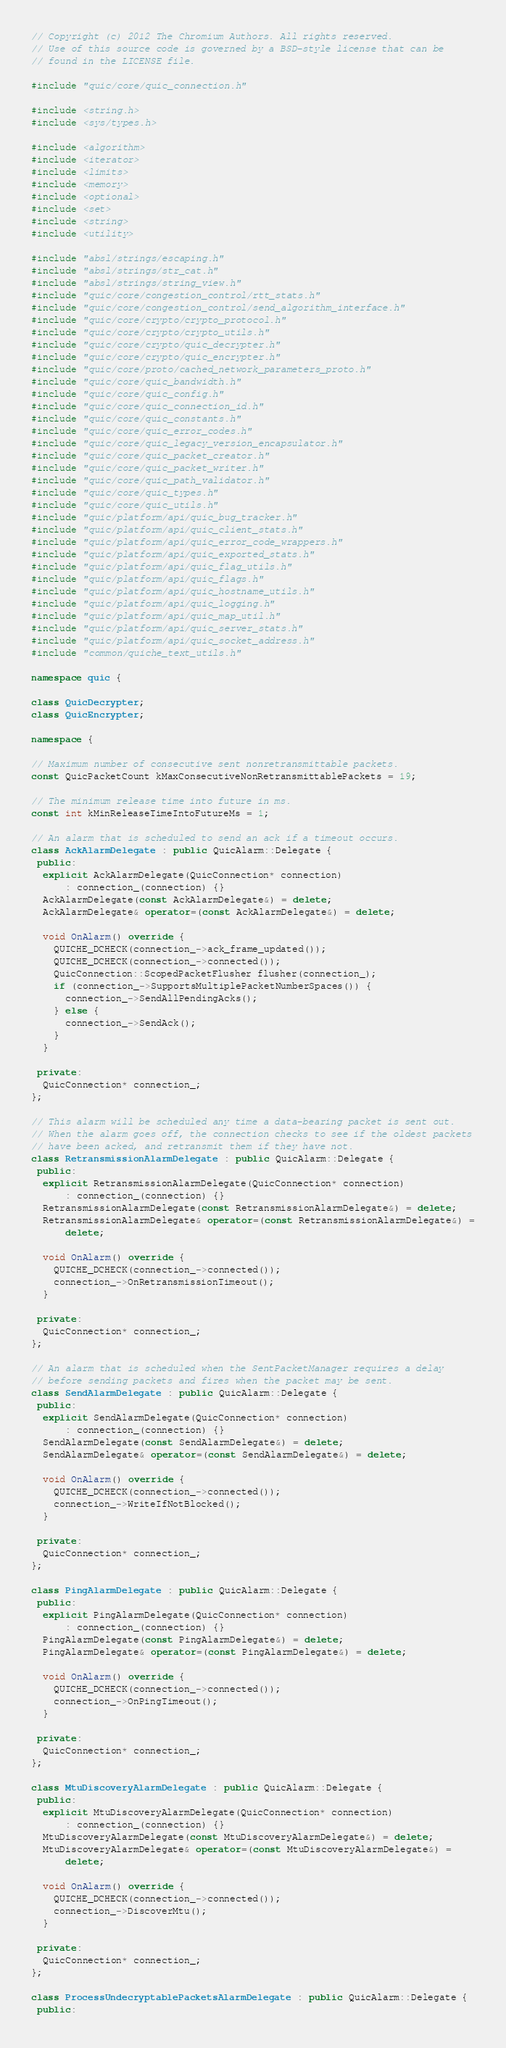Convert code to text. <code><loc_0><loc_0><loc_500><loc_500><_C++_>// Copyright (c) 2012 The Chromium Authors. All rights reserved.
// Use of this source code is governed by a BSD-style license that can be
// found in the LICENSE file.

#include "quic/core/quic_connection.h"

#include <string.h>
#include <sys/types.h>

#include <algorithm>
#include <iterator>
#include <limits>
#include <memory>
#include <optional>
#include <set>
#include <string>
#include <utility>

#include "absl/strings/escaping.h"
#include "absl/strings/str_cat.h"
#include "absl/strings/string_view.h"
#include "quic/core/congestion_control/rtt_stats.h"
#include "quic/core/congestion_control/send_algorithm_interface.h"
#include "quic/core/crypto/crypto_protocol.h"
#include "quic/core/crypto/crypto_utils.h"
#include "quic/core/crypto/quic_decrypter.h"
#include "quic/core/crypto/quic_encrypter.h"
#include "quic/core/proto/cached_network_parameters_proto.h"
#include "quic/core/quic_bandwidth.h"
#include "quic/core/quic_config.h"
#include "quic/core/quic_connection_id.h"
#include "quic/core/quic_constants.h"
#include "quic/core/quic_error_codes.h"
#include "quic/core/quic_legacy_version_encapsulator.h"
#include "quic/core/quic_packet_creator.h"
#include "quic/core/quic_packet_writer.h"
#include "quic/core/quic_path_validator.h"
#include "quic/core/quic_types.h"
#include "quic/core/quic_utils.h"
#include "quic/platform/api/quic_bug_tracker.h"
#include "quic/platform/api/quic_client_stats.h"
#include "quic/platform/api/quic_error_code_wrappers.h"
#include "quic/platform/api/quic_exported_stats.h"
#include "quic/platform/api/quic_flag_utils.h"
#include "quic/platform/api/quic_flags.h"
#include "quic/platform/api/quic_hostname_utils.h"
#include "quic/platform/api/quic_logging.h"
#include "quic/platform/api/quic_map_util.h"
#include "quic/platform/api/quic_server_stats.h"
#include "quic/platform/api/quic_socket_address.h"
#include "common/quiche_text_utils.h"

namespace quic {

class QuicDecrypter;
class QuicEncrypter;

namespace {

// Maximum number of consecutive sent nonretransmittable packets.
const QuicPacketCount kMaxConsecutiveNonRetransmittablePackets = 19;

// The minimum release time into future in ms.
const int kMinReleaseTimeIntoFutureMs = 1;

// An alarm that is scheduled to send an ack if a timeout occurs.
class AckAlarmDelegate : public QuicAlarm::Delegate {
 public:
  explicit AckAlarmDelegate(QuicConnection* connection)
      : connection_(connection) {}
  AckAlarmDelegate(const AckAlarmDelegate&) = delete;
  AckAlarmDelegate& operator=(const AckAlarmDelegate&) = delete;

  void OnAlarm() override {
    QUICHE_DCHECK(connection_->ack_frame_updated());
    QUICHE_DCHECK(connection_->connected());
    QuicConnection::ScopedPacketFlusher flusher(connection_);
    if (connection_->SupportsMultiplePacketNumberSpaces()) {
      connection_->SendAllPendingAcks();
    } else {
      connection_->SendAck();
    }
  }

 private:
  QuicConnection* connection_;
};

// This alarm will be scheduled any time a data-bearing packet is sent out.
// When the alarm goes off, the connection checks to see if the oldest packets
// have been acked, and retransmit them if they have not.
class RetransmissionAlarmDelegate : public QuicAlarm::Delegate {
 public:
  explicit RetransmissionAlarmDelegate(QuicConnection* connection)
      : connection_(connection) {}
  RetransmissionAlarmDelegate(const RetransmissionAlarmDelegate&) = delete;
  RetransmissionAlarmDelegate& operator=(const RetransmissionAlarmDelegate&) =
      delete;

  void OnAlarm() override {
    QUICHE_DCHECK(connection_->connected());
    connection_->OnRetransmissionTimeout();
  }

 private:
  QuicConnection* connection_;
};

// An alarm that is scheduled when the SentPacketManager requires a delay
// before sending packets and fires when the packet may be sent.
class SendAlarmDelegate : public QuicAlarm::Delegate {
 public:
  explicit SendAlarmDelegate(QuicConnection* connection)
      : connection_(connection) {}
  SendAlarmDelegate(const SendAlarmDelegate&) = delete;
  SendAlarmDelegate& operator=(const SendAlarmDelegate&) = delete;

  void OnAlarm() override {
    QUICHE_DCHECK(connection_->connected());
    connection_->WriteIfNotBlocked();
  }

 private:
  QuicConnection* connection_;
};

class PingAlarmDelegate : public QuicAlarm::Delegate {
 public:
  explicit PingAlarmDelegate(QuicConnection* connection)
      : connection_(connection) {}
  PingAlarmDelegate(const PingAlarmDelegate&) = delete;
  PingAlarmDelegate& operator=(const PingAlarmDelegate&) = delete;

  void OnAlarm() override {
    QUICHE_DCHECK(connection_->connected());
    connection_->OnPingTimeout();
  }

 private:
  QuicConnection* connection_;
};

class MtuDiscoveryAlarmDelegate : public QuicAlarm::Delegate {
 public:
  explicit MtuDiscoveryAlarmDelegate(QuicConnection* connection)
      : connection_(connection) {}
  MtuDiscoveryAlarmDelegate(const MtuDiscoveryAlarmDelegate&) = delete;
  MtuDiscoveryAlarmDelegate& operator=(const MtuDiscoveryAlarmDelegate&) =
      delete;

  void OnAlarm() override {
    QUICHE_DCHECK(connection_->connected());
    connection_->DiscoverMtu();
  }

 private:
  QuicConnection* connection_;
};

class ProcessUndecryptablePacketsAlarmDelegate : public QuicAlarm::Delegate {
 public:</code> 